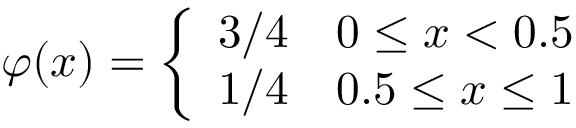Convert formula to latex. <formula><loc_0><loc_0><loc_500><loc_500>\varphi ( x ) = { \left \{ \begin{array} { l l } { 3 / 4 } & { 0 \leq x < 0 . 5 } \\ { 1 / 4 } & { 0 . 5 \leq x \leq 1 } \end{array} }</formula> 